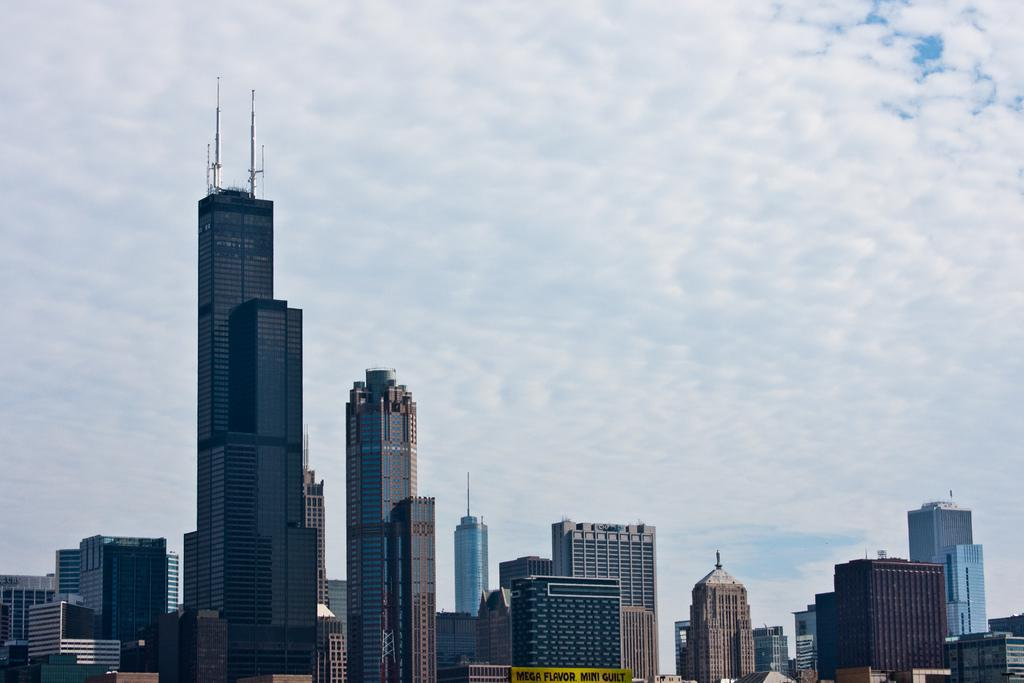What type of structures can be seen in the image? There are buildings in the image. What is visible in the background of the image? The sky is visible in the background of the image. What colors are present in the sky? The sky has a white and blue color. How many pairs of shoes can be seen on the buildings in the image? There are no shoes present on the buildings in the image. What type of body is visible in the image? There is no body present in the image; it features buildings and a sky. 